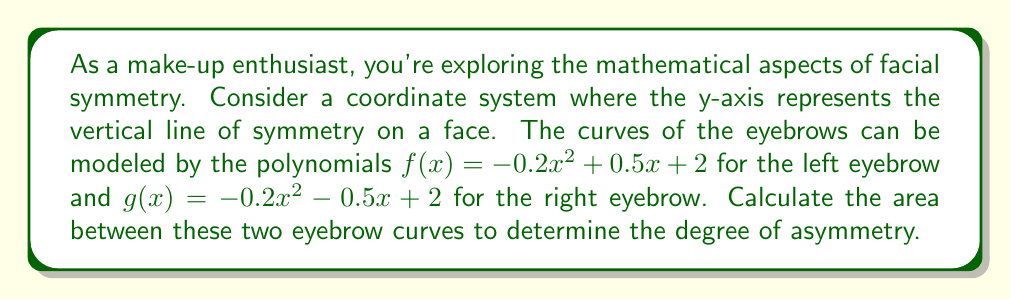Could you help me with this problem? To calculate the area between the two eyebrow curves, we need to follow these steps:

1) First, we need to find the points of intersection of the two curves. We can do this by setting the equations equal to each other:

   $-0.2x^2 + 0.5x + 2 = -0.2x^2 - 0.5x + 2$

2) Simplifying this equation:

   $0.5x + 2 = -0.5x + 2$
   $x = 0$

3) This means the curves intersect at x = 0, which represents the y-axis or the line of symmetry of the face.

4) To find the area between the curves, we need to integrate the difference of the two functions from -1 to 1 (assuming the face width is 2 units):

   $$ \text{Area} = \int_{-1}^{1} [f(x) - g(x)] dx $$

5) Substituting our functions:

   $$ \text{Area} = \int_{-1}^{1} [(-0.2x^2 + 0.5x + 2) - (-0.2x^2 - 0.5x + 2)] dx $$

6) Simplifying:

   $$ \text{Area} = \int_{-1}^{1} x dx $$

7) Integrating:

   $$ \text{Area} = [\frac{1}{2}x^2]_{-1}^{1} $$

8) Evaluating the integral:

   $$ \text{Area} = \frac{1}{2}(1)^2 - \frac{1}{2}(-1)^2 = \frac{1}{2} - \frac{1}{2} = 0 $$

The area between the curves is 0, indicating perfect symmetry between the eyebrows in this mathematical model.
Answer: The area between the eyebrow curves is 0 square units, indicating perfect symmetry in this model. 